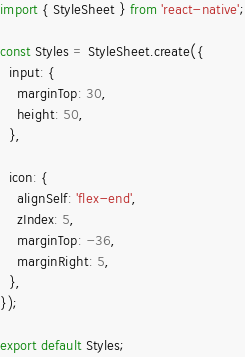Convert code to text. <code><loc_0><loc_0><loc_500><loc_500><_JavaScript_>import { StyleSheet } from 'react-native';

const Styles = StyleSheet.create({
  input: {
    marginTop: 30,
    height: 50,
  },

  icon: {
    alignSelf: 'flex-end',
    zIndex: 5,
    marginTop: -36,
    marginRight: 5,
  },
});

export default Styles;
</code> 